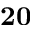<formula> <loc_0><loc_0><loc_500><loc_500>2 0</formula> 